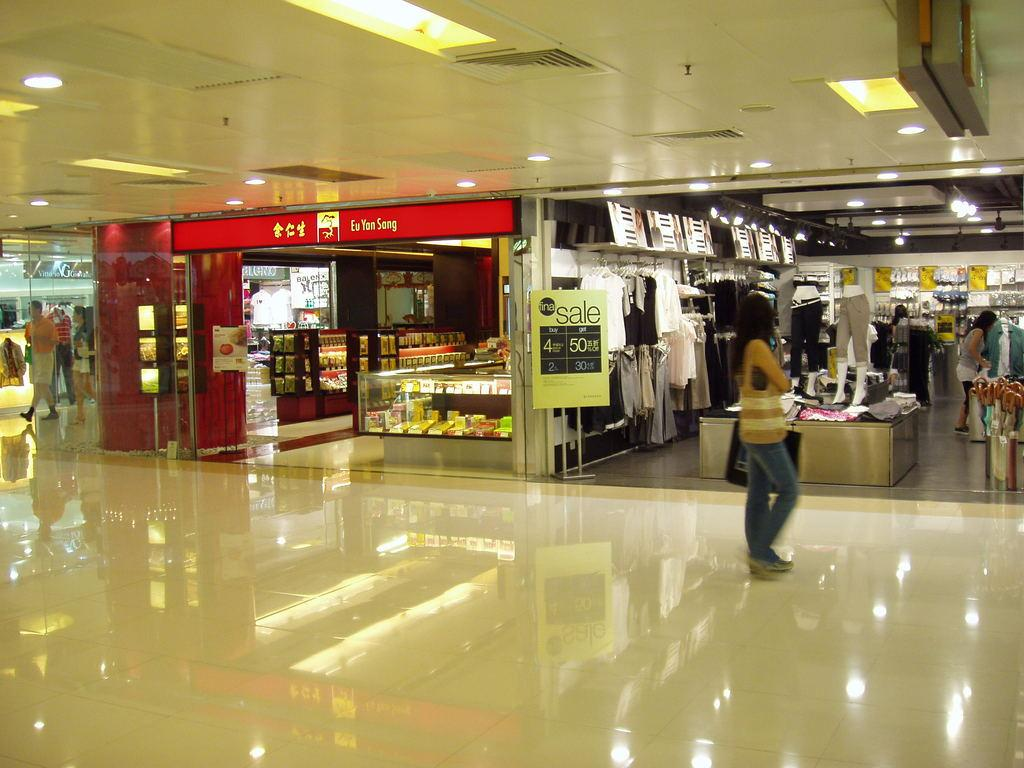What type of location is depicted in the image? The image shows the inside view of a mall. Can you describe any activity taking place in the image? There is a girl walking in the lobby. What type of stores can be seen in the mall? There are cloth shops visible in the image. How many forks are visible on the shelves of the cloth shops in the image? There are no forks visible in the image, as the stores are cloth shops and not kitchenware stores. Are there any cats visible in the image? There are no cats present in the image. 